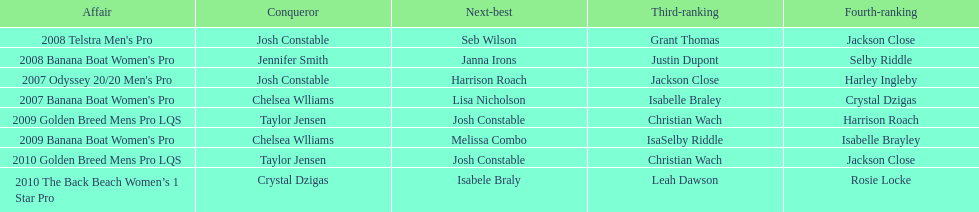How many times was josh constable the winner after 2007? 1. 